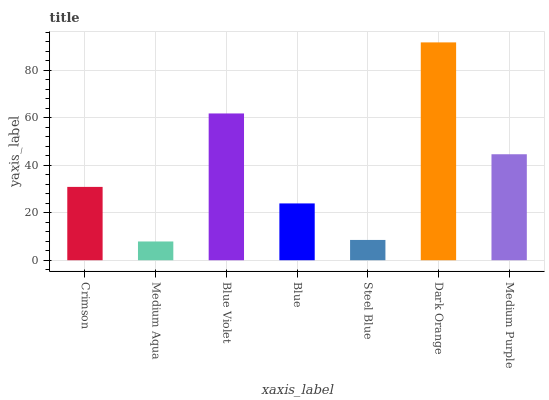Is Medium Aqua the minimum?
Answer yes or no. Yes. Is Dark Orange the maximum?
Answer yes or no. Yes. Is Blue Violet the minimum?
Answer yes or no. No. Is Blue Violet the maximum?
Answer yes or no. No. Is Blue Violet greater than Medium Aqua?
Answer yes or no. Yes. Is Medium Aqua less than Blue Violet?
Answer yes or no. Yes. Is Medium Aqua greater than Blue Violet?
Answer yes or no. No. Is Blue Violet less than Medium Aqua?
Answer yes or no. No. Is Crimson the high median?
Answer yes or no. Yes. Is Crimson the low median?
Answer yes or no. Yes. Is Steel Blue the high median?
Answer yes or no. No. Is Medium Aqua the low median?
Answer yes or no. No. 